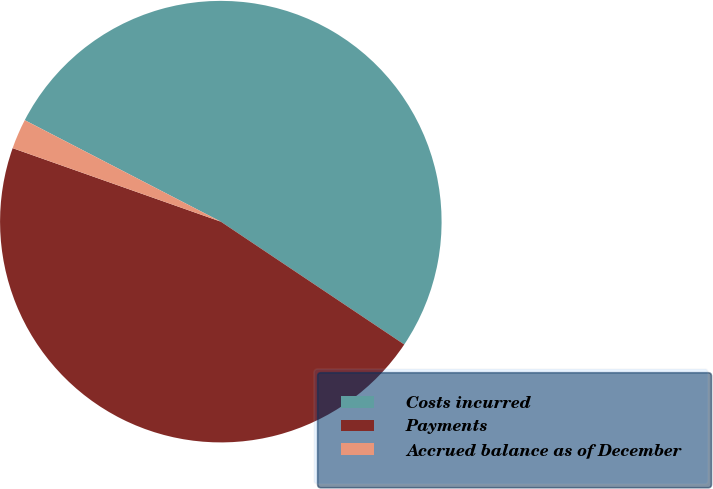Convert chart to OTSL. <chart><loc_0><loc_0><loc_500><loc_500><pie_chart><fcel>Costs incurred<fcel>Payments<fcel>Accrued balance as of December<nl><fcel>51.79%<fcel>46.01%<fcel>2.2%<nl></chart> 